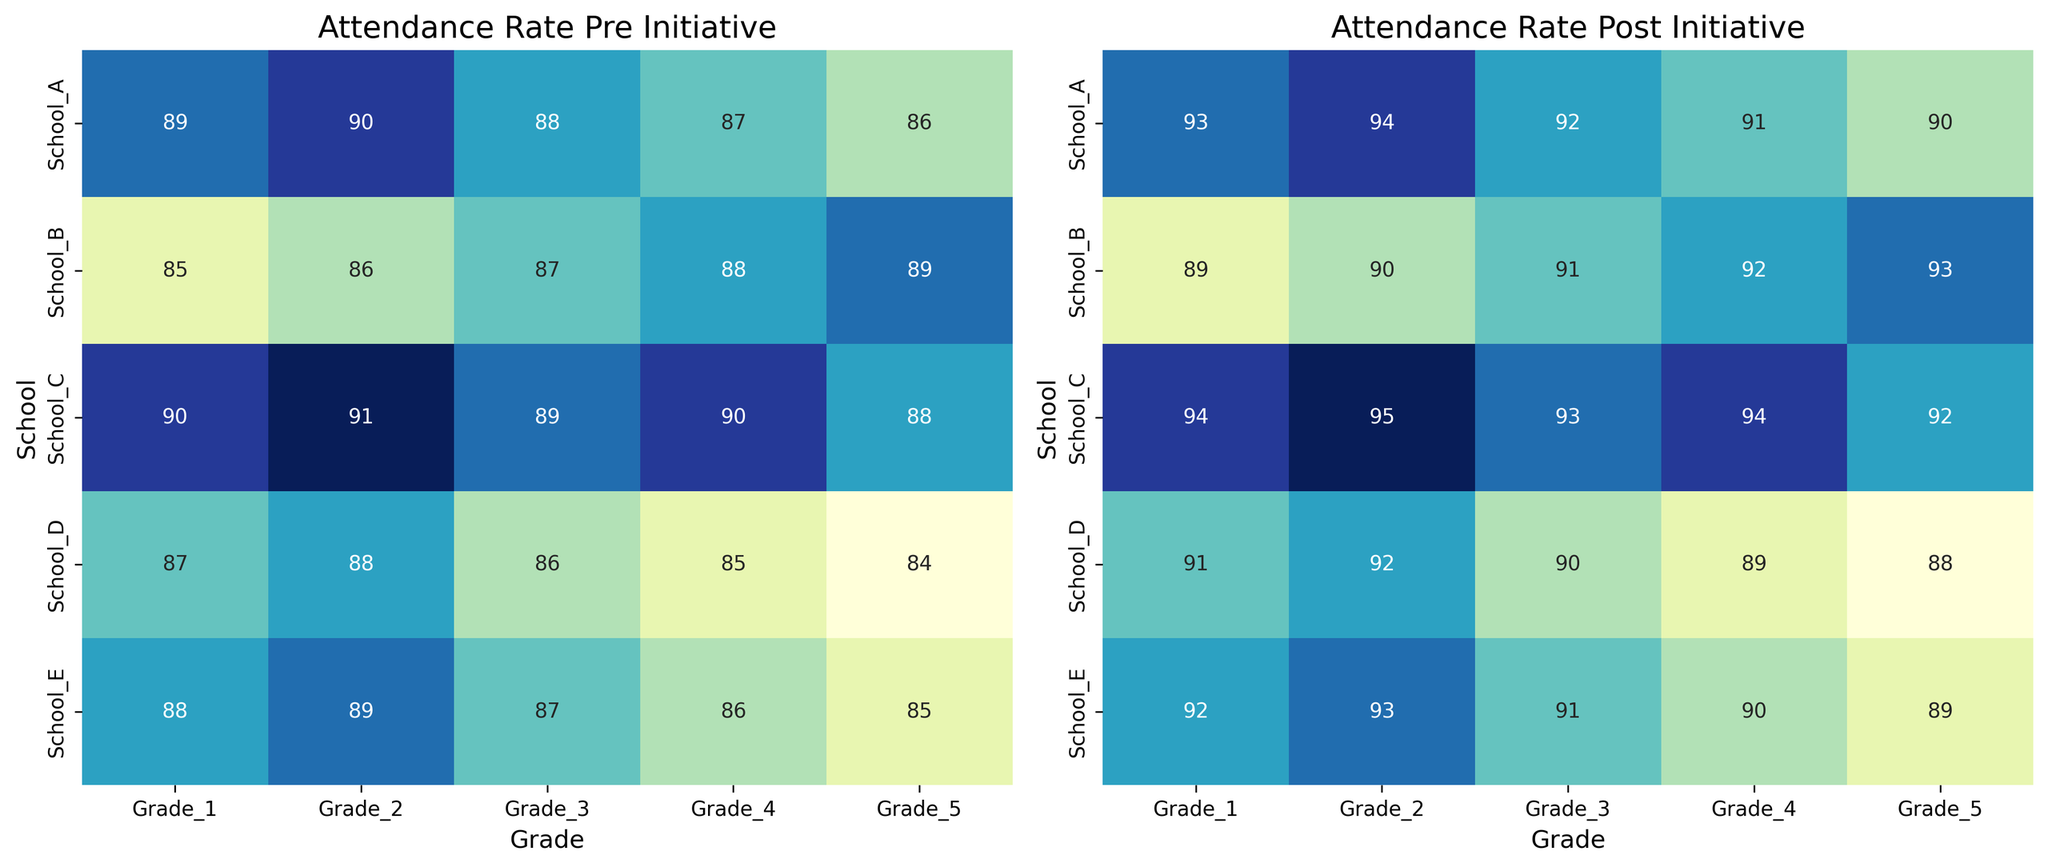Which school had the highest increase in Grade 3 attendance rate post-initiative? To find this, subtract the pre-initiative attendance rate from the post-initiative rate for Grade 3 in each school. School_A: 92-88=4, School_B: 91-87=4, School_C: 93-89=4, School_D: 90-86=4, School_E: 91-87=4. All schools had the same increase of 4%.
Answer: All schools Which grades in School_A had the same attendance rate post-initiative? Look at the values in School_A's row under "Attendance Rate Post Initiative". Grade 2 and Grade 4 both have an attendance rate of 92.
Answer: Grade 2 and Grade 4 What was the post-initiative attendance rate for Grade 5 in School_D? Locate the intersection of Grade 5 and School_D in the "Attendance Rate Post Initiative" heatmap. The value is 88%.
Answer: 88% Which school had the most consistent improvement across all grades? Consistency can be observed by calculating the difference for each grade (post minus pre) and comparing them. School_A: 4, 4, 4, 4, 4; School_B: 4, 4, 4, 4, 4; School_C: 4, 4, 4, 4, 4; School_D: 4, 4, 4, 4, 4; School_E: 4, 4, 4, 4, 4. All schools showed consistent improvement.
Answer: All schools How did the attendance rate for Grade 1 in School_C before the initiative compare to post-initiative? Look at School_C for Grade 1. Pre-initiative is 90%, and post-initiative is 94%.
Answer: Increased by 4% Which grade improved the most overall across all schools? Find the differences for each grade across all schools and sum them up. Grade 1: 4+4+4+4+4=20, Grade 2: 4+4+4+4+4=20, Grade 3: 4+4+4+4+4=20, Grade 4: 4+4+4+4+4=20, Grade 5: 4+4+4+4+4=20. All grades improved equally by a total of 20 points.
Answer: All grades What is the difference in the post-initiative attendance rates between Grade 2 and Grade 5 in School_B? Find the attendance rates post-initiative in School_B: Grade 2 is 90%, and Grade 5 is 93%. The difference is 93-90.
Answer: 3% Was there any school where the Grade 4 attendance rate pre-initiative was already higher than 90%? Check the "Attendance Rate Pre Initiative" for Grade 4 across all schools: School_A: 87, School_B: 88, School_C: 90, School_D: 85, School_E: 86. None of the schools had a pre-initiative attendance rate above 90% for Grade 4.
Answer: No Which school's Grade 5 attendance rate had the smallest improvement? Calculate the difference between pre and post-initiative rates for Grade 5 in each school: School_A: 90-86=4, School_B: 93-89=4, School_C: 92-88=4, School_D: 88-84=4, School_E: 89-85=4. All schools had the same improvement of 4%.
Answer: All schools Which grade in School_E had the highest attendance rate post-initiative? Compare the post-initiative attendance rates for all grades in School_E. Grade 2 has a rate of 93%, which is the highest among all grades within this school.
Answer: Grade 2 